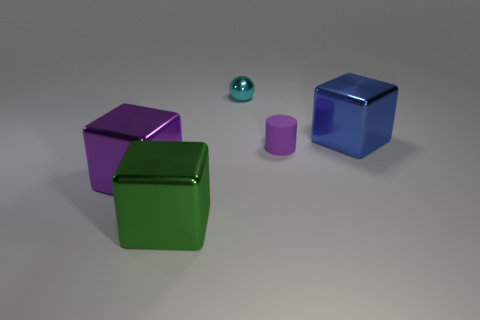What shape is the metal object that is the same color as the tiny rubber cylinder?
Your answer should be compact. Cube. What material is the big green thing?
Offer a very short reply. Metal. What is the size of the thing that is the same color as the rubber cylinder?
Give a very brief answer. Large. Does the large green thing have the same shape as the purple object on the right side of the large green shiny object?
Your answer should be very brief. No. What material is the tiny object behind the big metal thing that is on the right side of the big green thing in front of the cylinder made of?
Offer a very short reply. Metal. What number of purple matte cylinders are there?
Keep it short and to the point. 1. How many green objects are either large metallic objects or tiny shiny objects?
Make the answer very short. 1. How many other objects are the same shape as the big purple object?
Make the answer very short. 2. There is a small object that is in front of the ball; does it have the same color as the shiny cube that is right of the shiny sphere?
Provide a short and direct response. No. What number of tiny things are either purple things or cyan metallic balls?
Offer a very short reply. 2. 